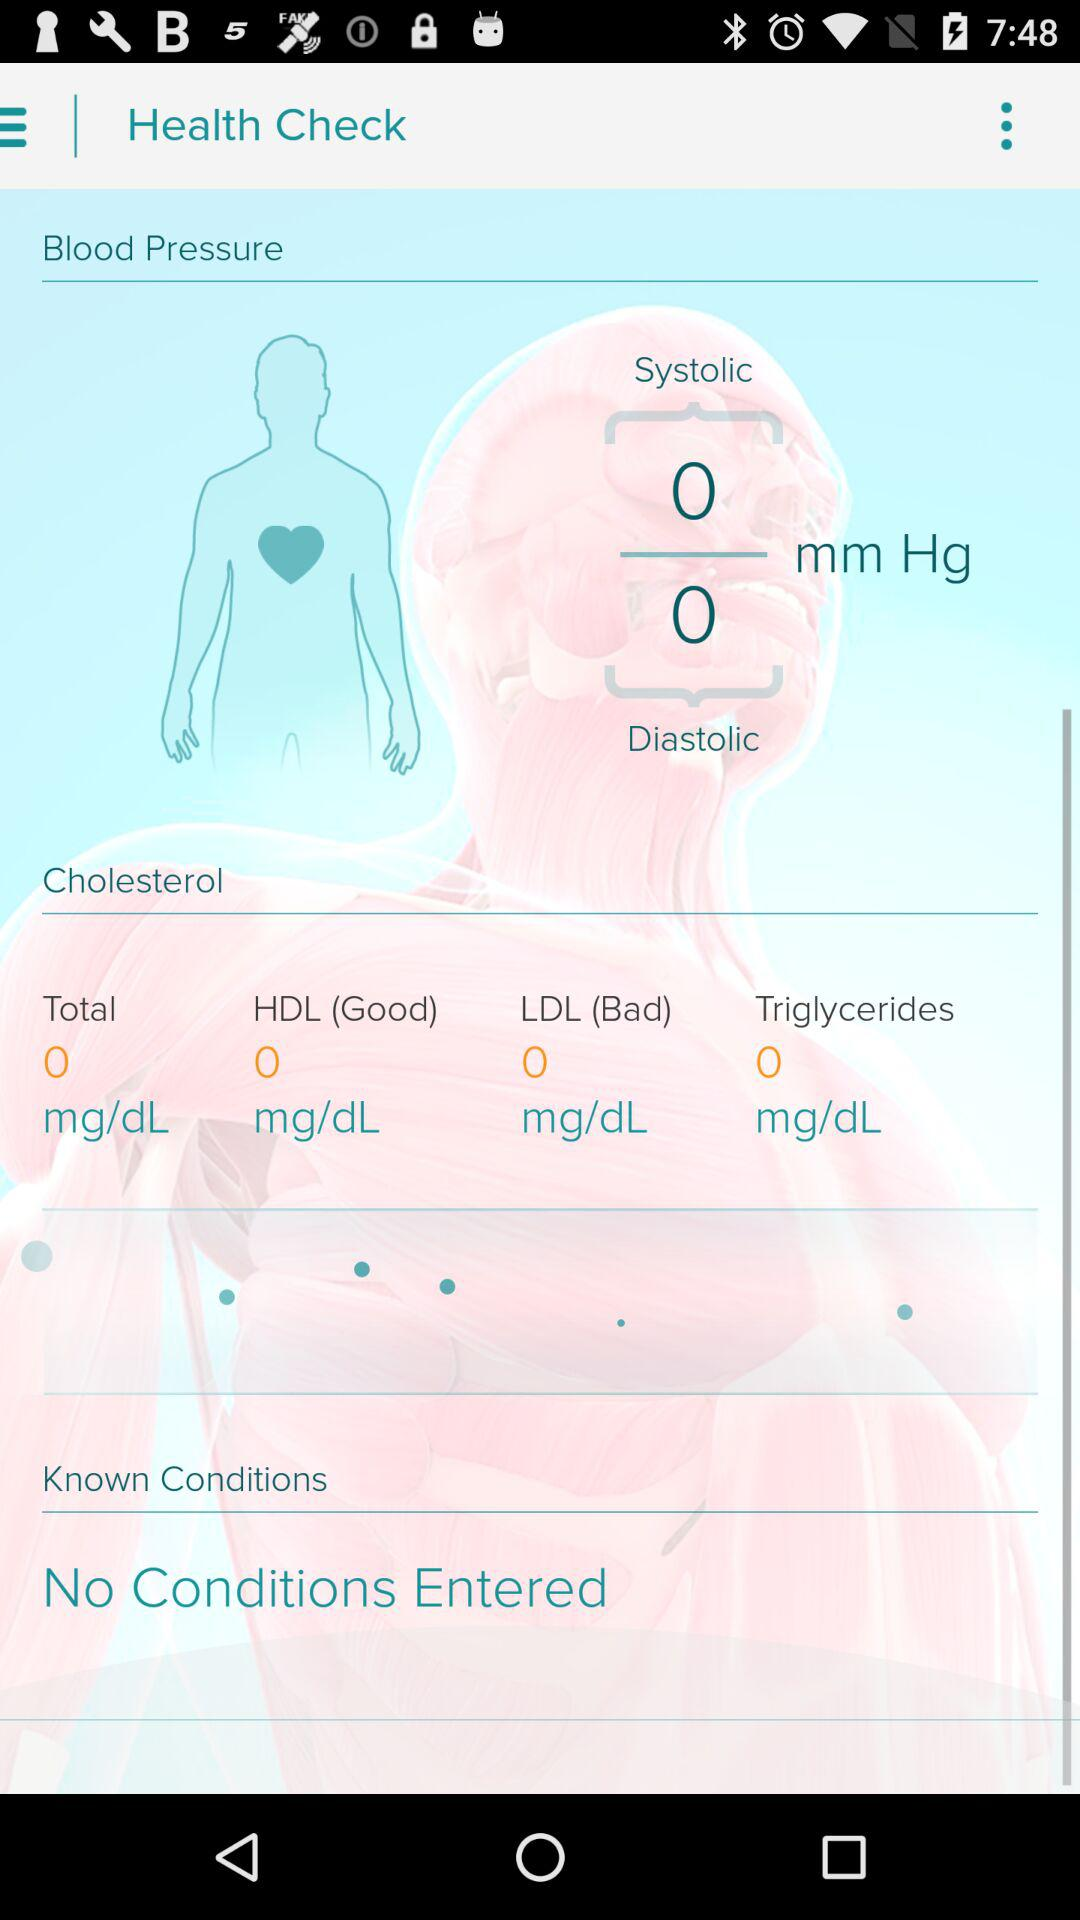What is the total cholesterol value in mg/dL? The total cholesterol value in milligrams per deciliter is 0. 